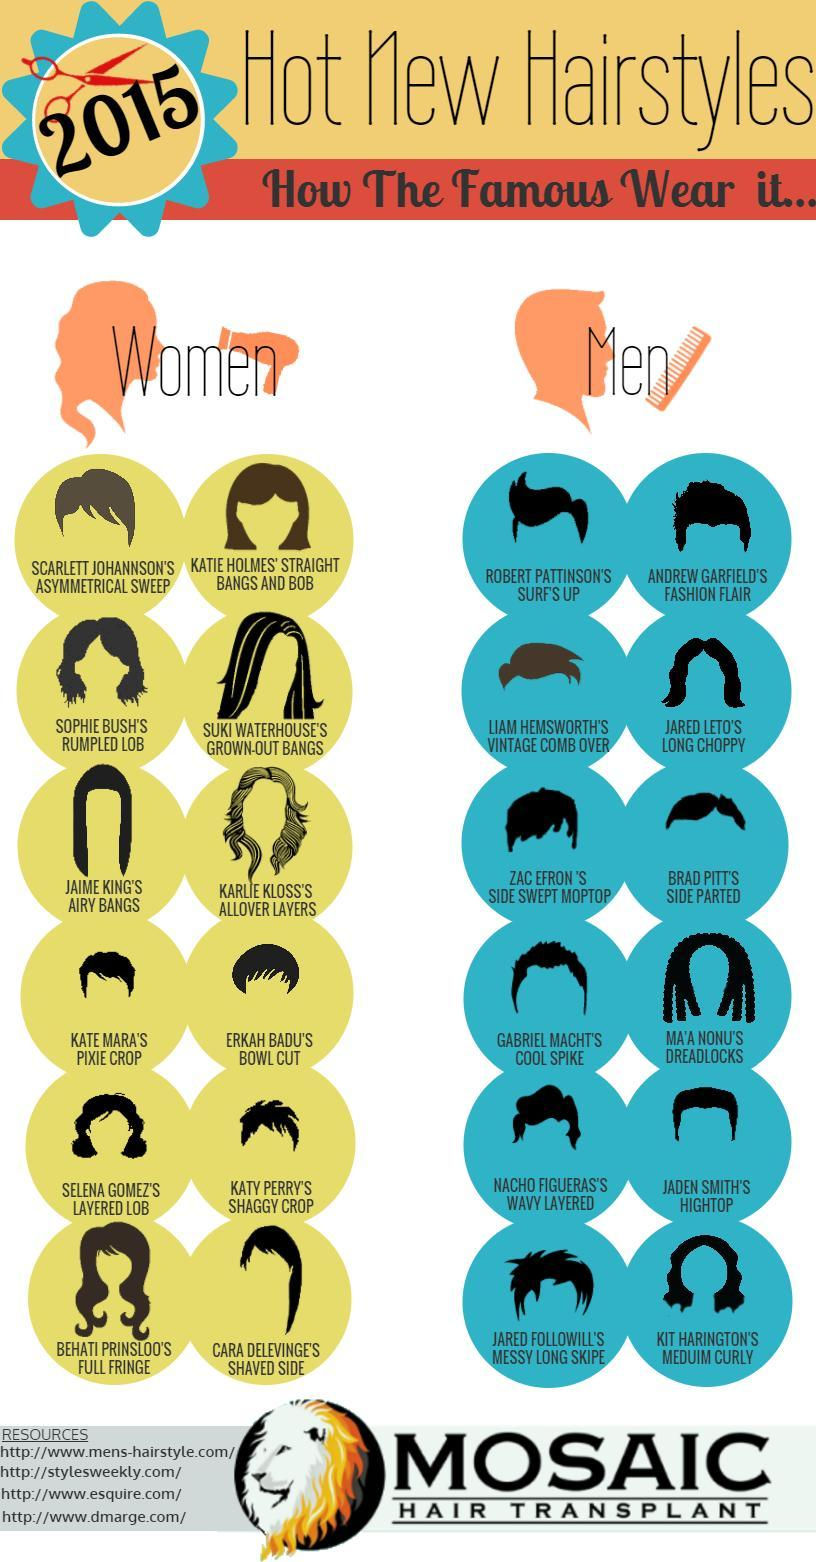How many short hair styles are there for women?
Answer the question with a short phrase. 4 Which celebrity wears a side parted hairstyle? BRAD PITT What is the name of the hairstyle worn by Jared Leto? Long Choppy Who has a hairstyle that resembles a bowl? ERKAH BADU What is the name of the hairstyle worn by Katy Perry? SHAGGY CROP 